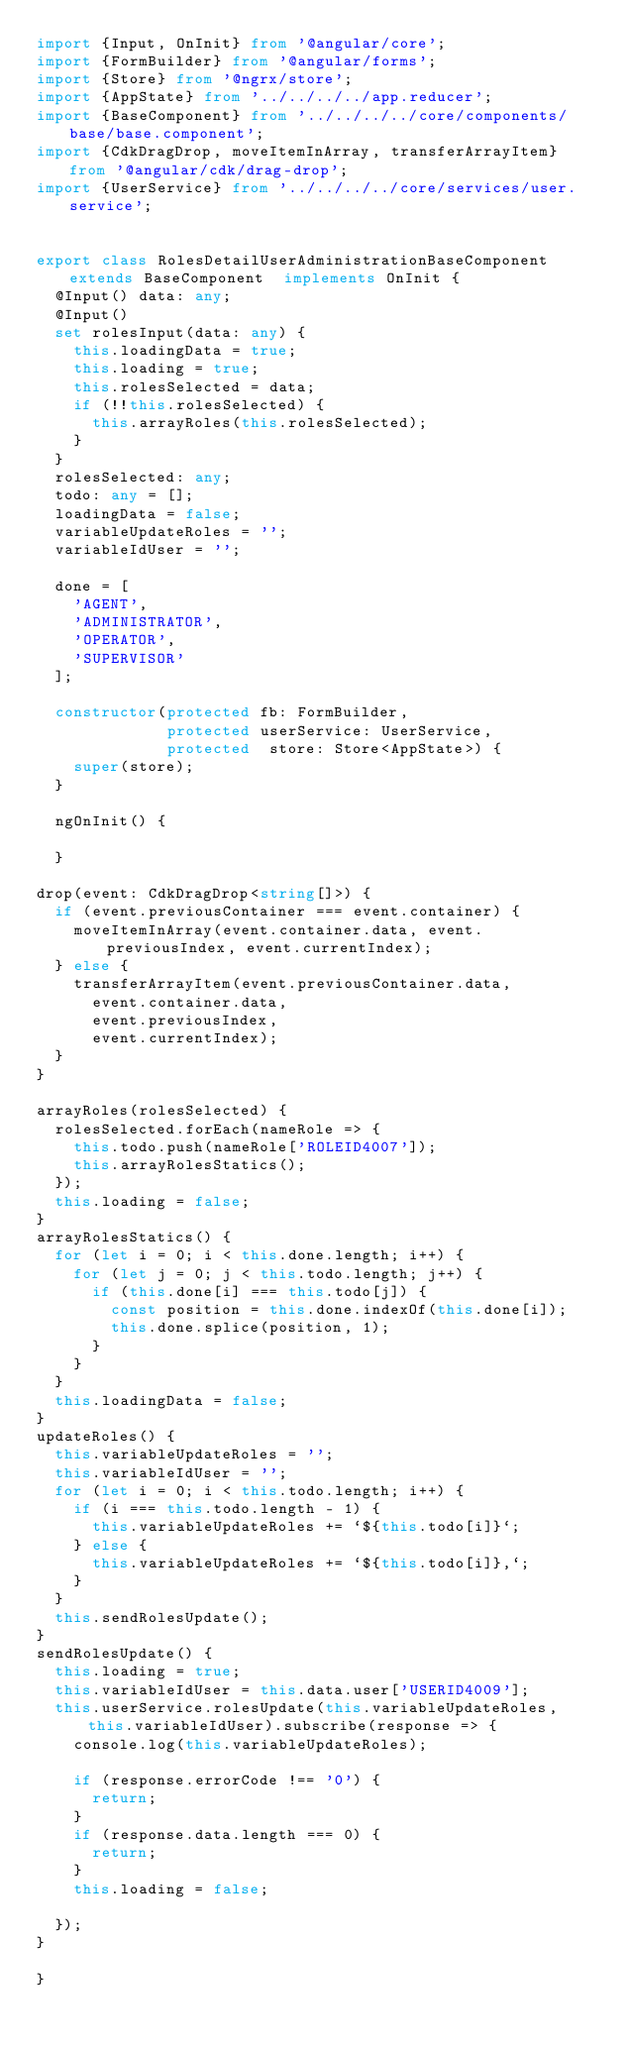<code> <loc_0><loc_0><loc_500><loc_500><_TypeScript_>import {Input, OnInit} from '@angular/core';
import {FormBuilder} from '@angular/forms';
import {Store} from '@ngrx/store';
import {AppState} from '../../../../app.reducer';
import {BaseComponent} from '../../../../core/components/base/base.component';
import {CdkDragDrop, moveItemInArray, transferArrayItem} from '@angular/cdk/drag-drop';
import {UserService} from '../../../../core/services/user.service';


export class RolesDetailUserAdministrationBaseComponent extends BaseComponent  implements OnInit {
  @Input() data: any;
  @Input()
  set rolesInput(data: any) {
    this.loadingData = true;
    this.loading = true;
    this.rolesSelected = data;
    if (!!this.rolesSelected) {
      this.arrayRoles(this.rolesSelected);
    }
  }
  rolesSelected: any;
  todo: any = [];
  loadingData = false;
  variableUpdateRoles = '';
  variableIdUser = '';

  done = [
    'AGENT',
    'ADMINISTRATOR',
    'OPERATOR',
    'SUPERVISOR'
  ];

  constructor(protected fb: FormBuilder,
              protected userService: UserService,
              protected  store: Store<AppState>) {
    super(store);
  }

  ngOnInit() {

  }

drop(event: CdkDragDrop<string[]>) {
  if (event.previousContainer === event.container) {
    moveItemInArray(event.container.data, event.previousIndex, event.currentIndex);
  } else {
    transferArrayItem(event.previousContainer.data,
      event.container.data,
      event.previousIndex,
      event.currentIndex);
  }
}

arrayRoles(rolesSelected) {
  rolesSelected.forEach(nameRole => {
    this.todo.push(nameRole['ROLEID4007']);
    this.arrayRolesStatics();
  });
  this.loading = false;
}
arrayRolesStatics() {
  for (let i = 0; i < this.done.length; i++) {
    for (let j = 0; j < this.todo.length; j++) {
      if (this.done[i] === this.todo[j]) {
        const position = this.done.indexOf(this.done[i]);
        this.done.splice(position, 1);
      }
    }
  }
  this.loadingData = false;
}
updateRoles() {
  this.variableUpdateRoles = '';
  this.variableIdUser = '';
  for (let i = 0; i < this.todo.length; i++) {
    if (i === this.todo.length - 1) {
      this.variableUpdateRoles += `${this.todo[i]}`;
    } else {
      this.variableUpdateRoles += `${this.todo[i]},`;
    }
  }
  this.sendRolesUpdate();
}
sendRolesUpdate() {
  this.loading = true;
  this.variableIdUser = this.data.user['USERID4009'];
  this.userService.rolesUpdate(this.variableUpdateRoles, this.variableIdUser).subscribe(response => {
    console.log(this.variableUpdateRoles);

    if (response.errorCode !== '0') {
      return;
    }
    if (response.data.length === 0) {
      return;
    }
    this.loading = false;

  });
}

}
</code> 